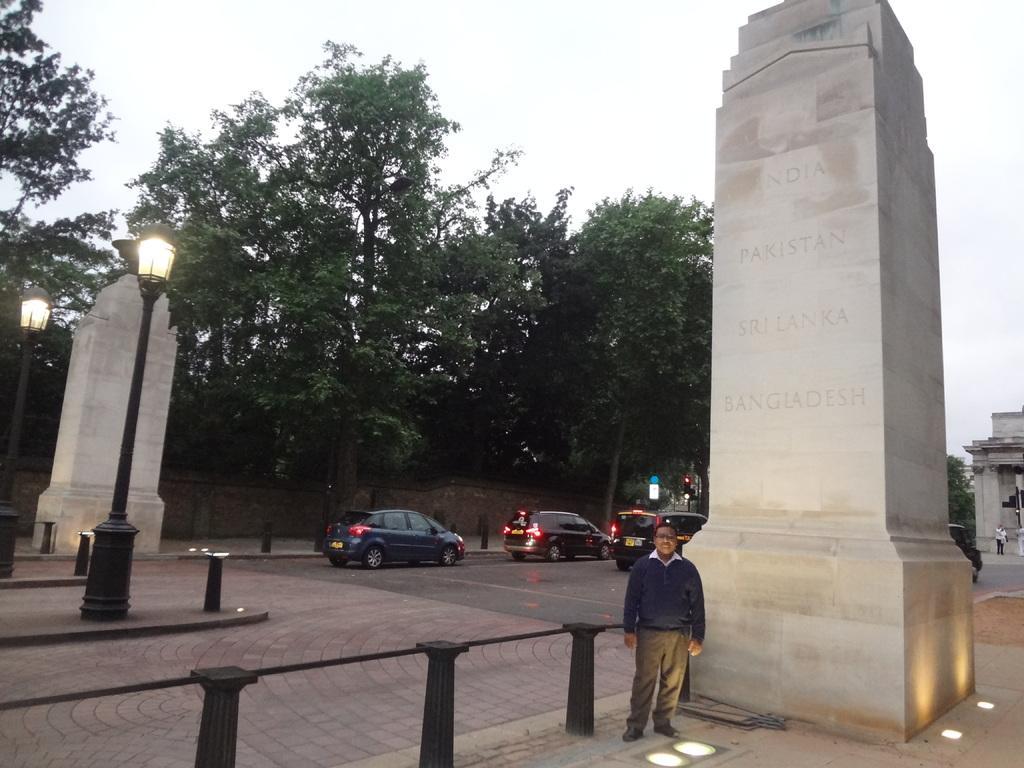Can you describe this image briefly? In this picture there are two headstones on the right and left side of the image, there are lamp poles on the left side of the image and there is a man who is standing at the bottom side of the image and there are cars and trees in the background area of the image. 